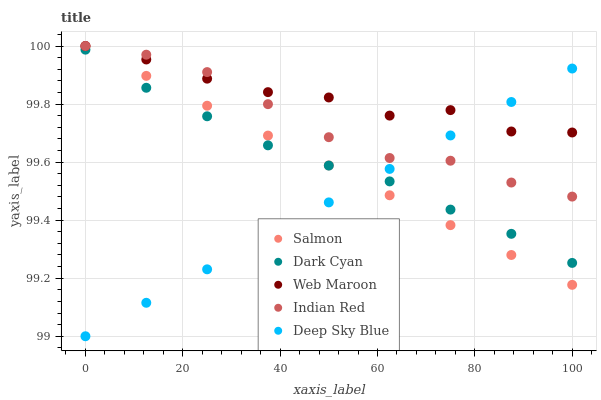Does Deep Sky Blue have the minimum area under the curve?
Answer yes or no. Yes. Does Web Maroon have the maximum area under the curve?
Answer yes or no. Yes. Does Salmon have the minimum area under the curve?
Answer yes or no. No. Does Salmon have the maximum area under the curve?
Answer yes or no. No. Is Salmon the smoothest?
Answer yes or no. Yes. Is Web Maroon the roughest?
Answer yes or no. Yes. Is Web Maroon the smoothest?
Answer yes or no. No. Is Salmon the roughest?
Answer yes or no. No. Does Deep Sky Blue have the lowest value?
Answer yes or no. Yes. Does Salmon have the lowest value?
Answer yes or no. No. Does Indian Red have the highest value?
Answer yes or no. Yes. Does Deep Sky Blue have the highest value?
Answer yes or no. No. Is Dark Cyan less than Indian Red?
Answer yes or no. Yes. Is Web Maroon greater than Dark Cyan?
Answer yes or no. Yes. Does Salmon intersect Dark Cyan?
Answer yes or no. Yes. Is Salmon less than Dark Cyan?
Answer yes or no. No. Is Salmon greater than Dark Cyan?
Answer yes or no. No. Does Dark Cyan intersect Indian Red?
Answer yes or no. No. 